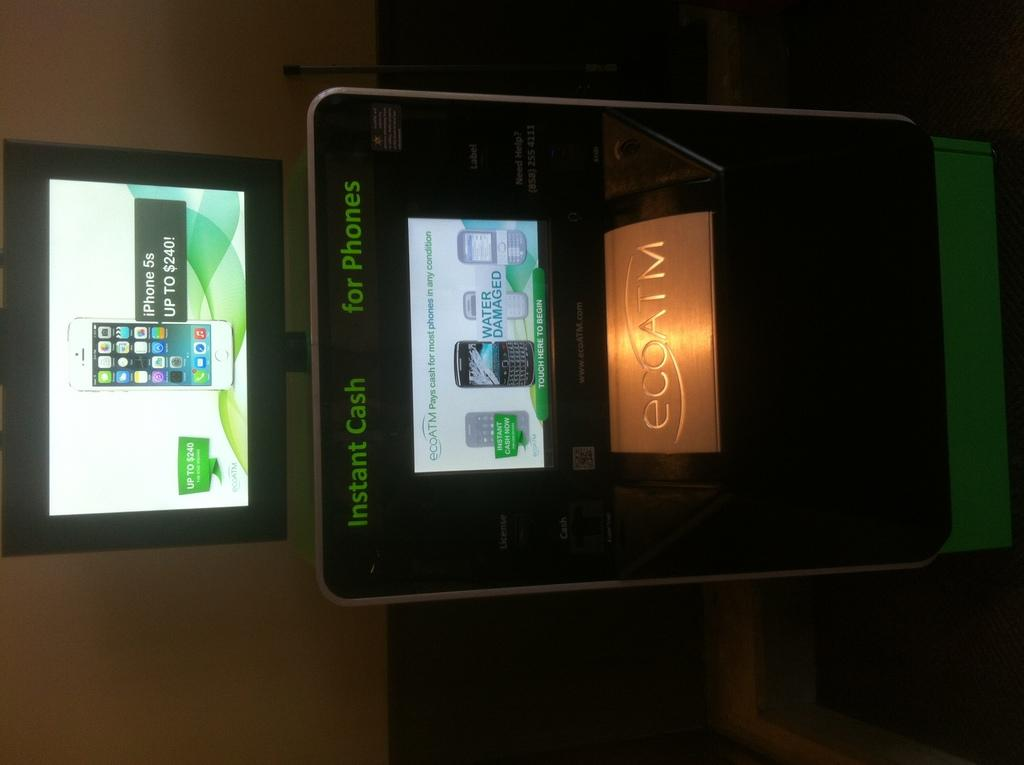<image>
Give a short and clear explanation of the subsequent image. A digital sign advertises instant cash for phones. 